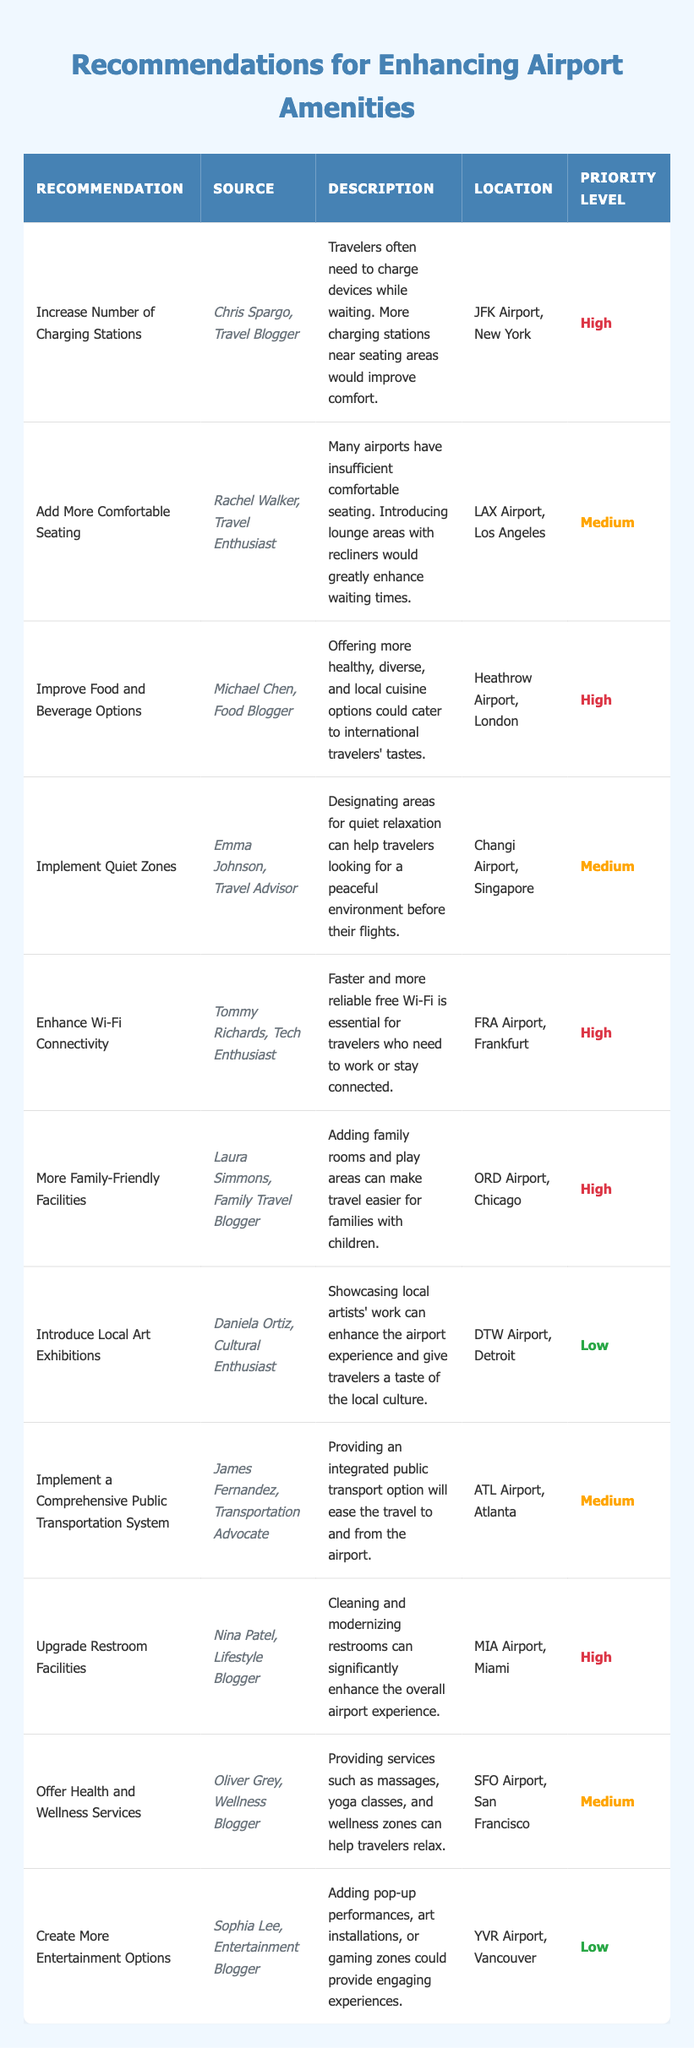What is the highest priority recommendation in the table? The table lists several recommendations with priority levels. Scanning through the 'Priority Level' column, the recommendation with the highest priority, labeled "High," includes several entries. The first one listed is "Increase Number of Charging Stations."
Answer: Increase Number of Charging Stations How many recommendations are marked as 'Medium' priority? By examining the 'Priority Level' column, there are three entries with 'Medium' priority: "Add More Comfortable Seating," "Implement Quiet Zones," and "Offer Health and Wellness Services." Counting them gives a total of three.
Answer: 3 Which airport is suggested for enhancing food and beverage options? The 'Location' column can be checked against the recommendation for enhancing food and beverage options. The specific recommendation is linked to "Heathrow Airport, London."
Answer: Heathrow Airport, London Is there a recommendation for upgrading restroom facilities? Looking for the phrase "Upgrade Restroom Facilities" in the 'Recommendation' column confirms that such a recommendation exists.
Answer: Yes What is the difference between the number of 'High' and 'Low' priority recommendations? Counting the items in the table reveals 6 'High' priority recommendations and 3 'Low' priority recommendations. The difference is calculated as 6 - 3 = 3.
Answer: 3 Which recommendation has a source from a family travel blogger? Scanning through the 'Source' column, "More Family-Friendly Facilities" corresponds to Laura Simmons, identified as a Family Travel Blogger.
Answer: More Family-Friendly Facilities What percentage of the recommendations are related to improving facilities for families? The total number of recommendations is 10, with only 1 recommendation specifically for families, which is "More Family-Friendly Facilities." The percentage is calculated as (1/10) * 100 = 10%.
Answer: 10% Identify the source of the recommendation to create more entertainment options. The recommendation "Create More Entertainment Options" is associated with the source "Sophia Lee, Entertainment Blogger" found in the 'Source' column.
Answer: Sophia Lee, Entertainment Blogger Which location suggests implementing quiet zones? The recommendation regarding quiet zones can be found in the 'Description' column alongside "Changi Airport, Singapore" in the 'Location' column.
Answer: Changi Airport, Singapore How many total recommendations are related to enhancing connectivity (charging stations, Wi-Fi, and public transport)? The relevant recommendations are "Increase Number of Charging Stations," "Enhance Wi-Fi Connectivity," and "Implement a Comprehensive Public Transportation System." There are 3 recommendations related to enhancing connectivity.
Answer: 3 What improvements could benefit international travelers according to the recommendations? Scanning through recommendations shows "Improve Food and Beverage Options" as a key suggestion for catering to international travelers' tastes. It's primarily focused on diverse and local cuisine options.
Answer: Improve Food and Beverage Options 